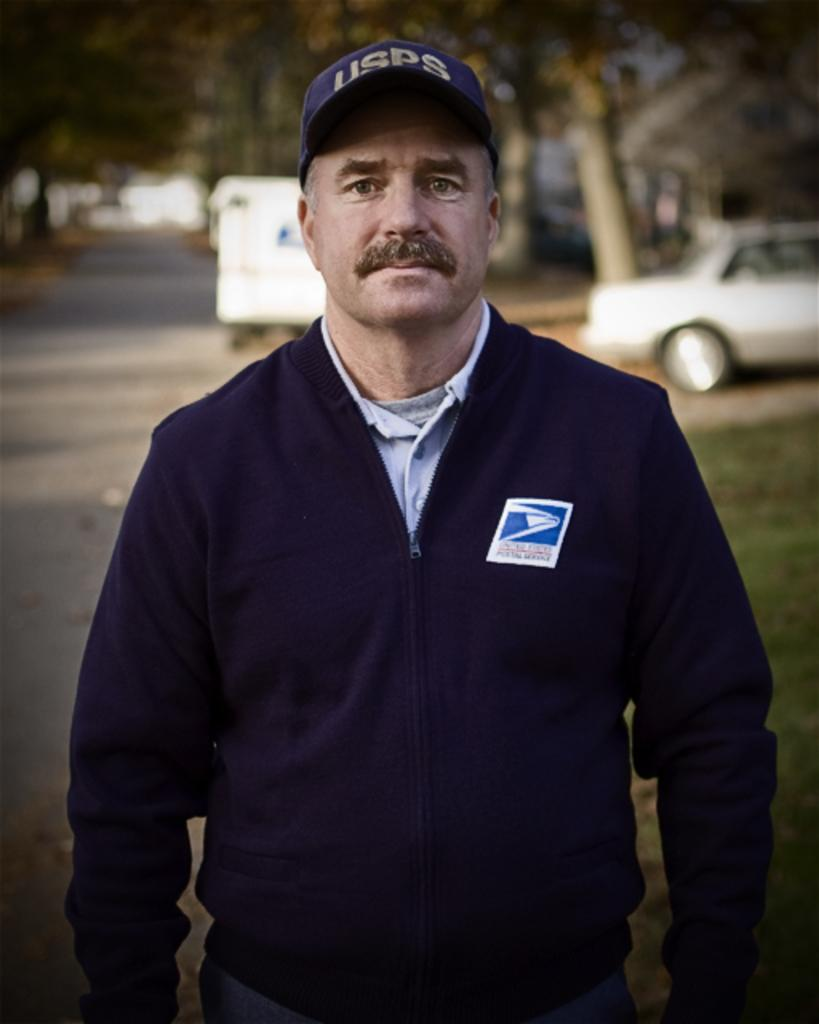Who is present in the image? There is a person in the image. What is the person wearing? The person is wearing a blue dress and a cap. What can be seen in the background of the image? There is a car and trees in the background of the image. How much money is the person holding in the image? There is no indication in the image that the person is holding money. What type of fowl can be seen in the image? There are no fowl present in the image. 